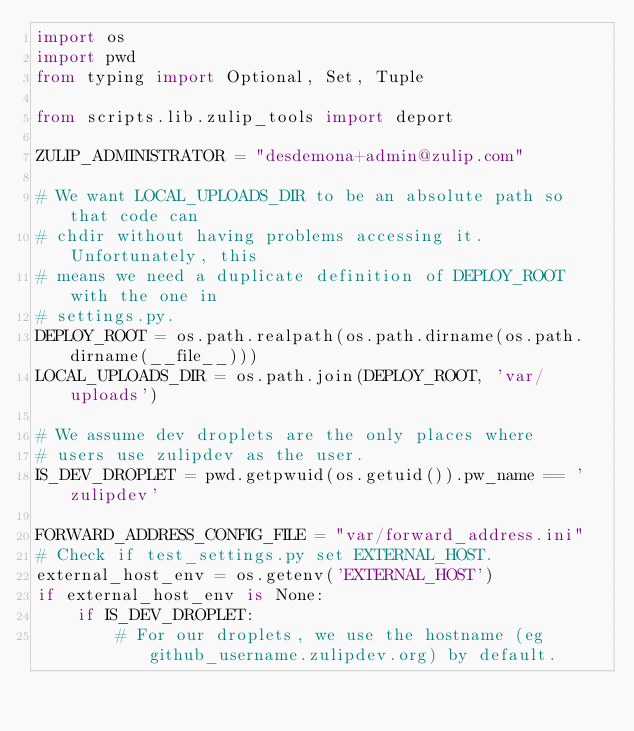<code> <loc_0><loc_0><loc_500><loc_500><_Python_>import os
import pwd
from typing import Optional, Set, Tuple

from scripts.lib.zulip_tools import deport

ZULIP_ADMINISTRATOR = "desdemona+admin@zulip.com"

# We want LOCAL_UPLOADS_DIR to be an absolute path so that code can
# chdir without having problems accessing it.  Unfortunately, this
# means we need a duplicate definition of DEPLOY_ROOT with the one in
# settings.py.
DEPLOY_ROOT = os.path.realpath(os.path.dirname(os.path.dirname(__file__)))
LOCAL_UPLOADS_DIR = os.path.join(DEPLOY_ROOT, 'var/uploads')

# We assume dev droplets are the only places where
# users use zulipdev as the user.
IS_DEV_DROPLET = pwd.getpwuid(os.getuid()).pw_name == 'zulipdev'

FORWARD_ADDRESS_CONFIG_FILE = "var/forward_address.ini"
# Check if test_settings.py set EXTERNAL_HOST.
external_host_env = os.getenv('EXTERNAL_HOST')
if external_host_env is None:
    if IS_DEV_DROPLET:
        # For our droplets, we use the hostname (eg github_username.zulipdev.org) by default.</code> 